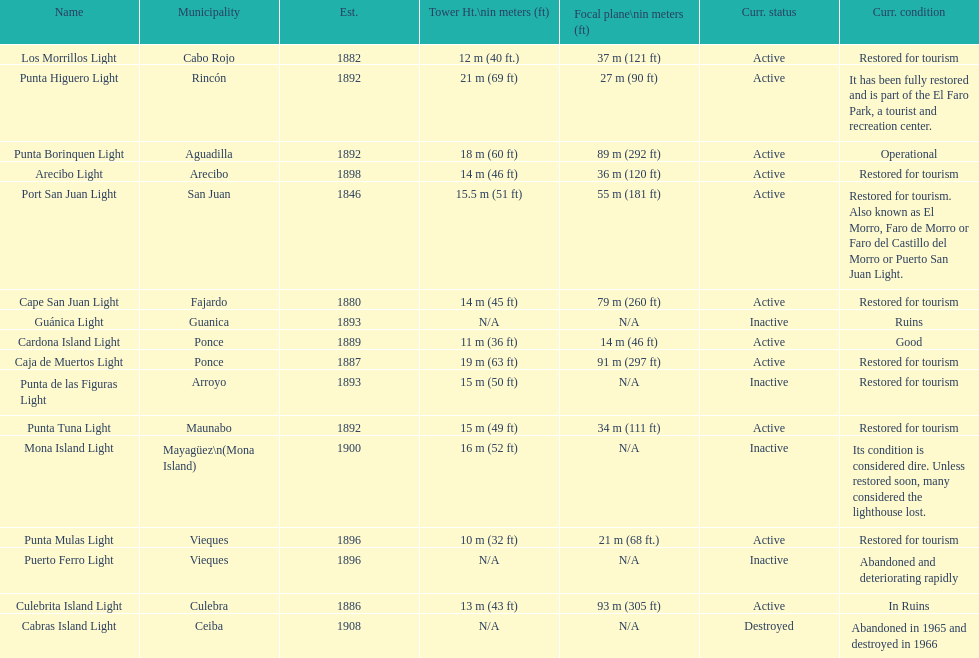How many establishments are restored for tourism? 9. 